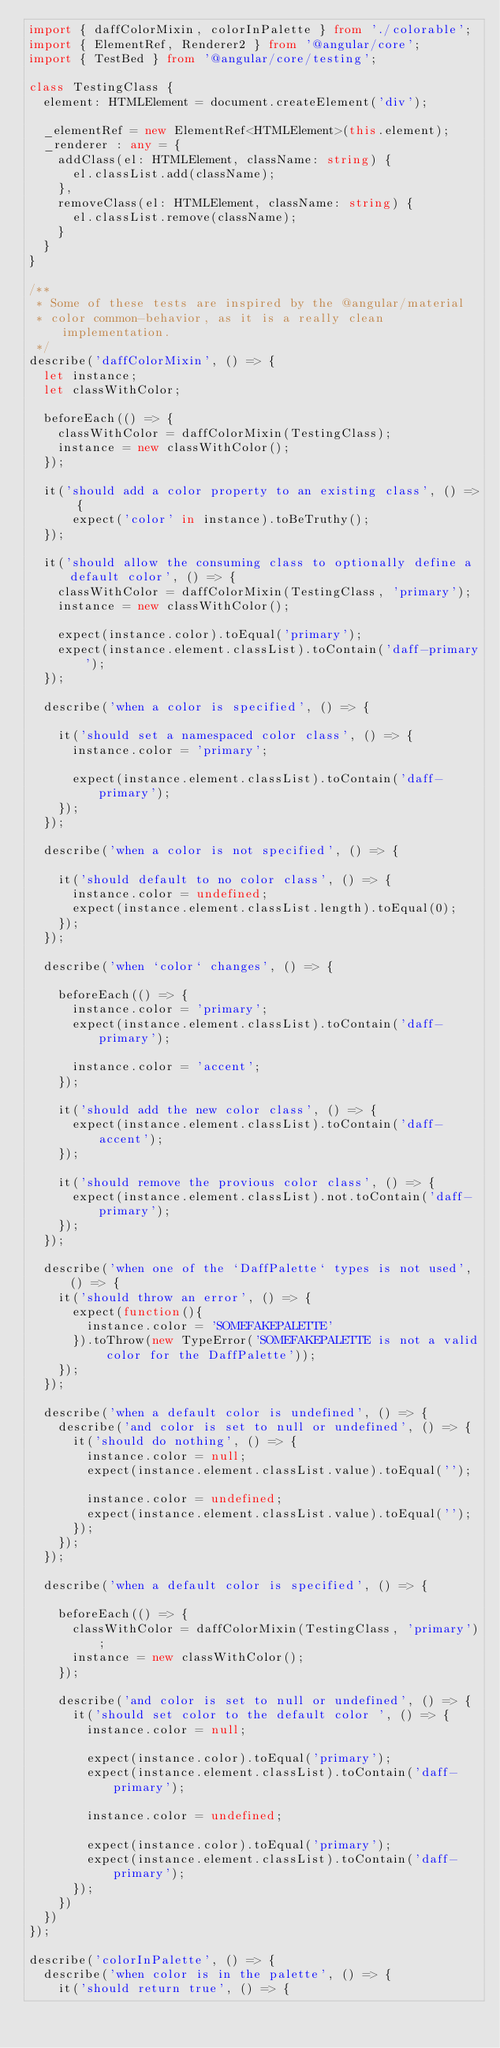Convert code to text. <code><loc_0><loc_0><loc_500><loc_500><_TypeScript_>import { daffColorMixin, colorInPalette } from './colorable';
import { ElementRef, Renderer2 } from '@angular/core';
import { TestBed } from '@angular/core/testing';

class TestingClass {
  element: HTMLElement = document.createElement('div');

  _elementRef = new ElementRef<HTMLElement>(this.element);
  _renderer : any = { 
    addClass(el: HTMLElement, className: string) {
      el.classList.add(className);
    },
    removeClass(el: HTMLElement, className: string) {
      el.classList.remove(className);
    }
  } 
}

/**
 * Some of these tests are inspired by the @angular/material
 * color common-behavior, as it is a really clean implementation.
 */
describe('daffColorMixin', () => {
  let instance;
  let classWithColor;

  beforeEach(() => {
    classWithColor = daffColorMixin(TestingClass);
    instance = new classWithColor();
  });

  it('should add a color property to an existing class', () => {
      expect('color' in instance).toBeTruthy();
  });

  it('should allow the consuming class to optionally define a default color', () => {
    classWithColor = daffColorMixin(TestingClass, 'primary');
    instance = new classWithColor();

    expect(instance.color).toEqual('primary');
    expect(instance.element.classList).toContain('daff-primary');
  });

  describe('when a color is specified', () => {
    
    it('should set a namespaced color class', () => {
      instance.color = 'primary';

      expect(instance.element.classList).toContain('daff-primary');
    });
  });

  describe('when a color is not specified', () => {
    
    it('should default to no color class', () => {
      instance.color = undefined;
      expect(instance.element.classList.length).toEqual(0);
    });
  });

  describe('when `color` changes', () => {

    beforeEach(() => {
      instance.color = 'primary';
      expect(instance.element.classList).toContain('daff-primary');

      instance.color = 'accent';
    });
    
    it('should add the new color class', () => {
      expect(instance.element.classList).toContain('daff-accent');
    });

    it('should remove the provious color class', () => {
      expect(instance.element.classList).not.toContain('daff-primary');
    });
  });

  describe('when one of the `DaffPalette` types is not used', () => {
    it('should throw an error', () => {
      expect(function(){
        instance.color = 'SOMEFAKEPALETTE'
      }).toThrow(new TypeError('SOMEFAKEPALETTE is not a valid color for the DaffPalette'));
    });
  });

  describe('when a default color is undefined', () => {
    describe('and color is set to null or undefined', () => {
      it('should do nothing', () => {
        instance.color = null;
        expect(instance.element.classList.value).toEqual('');

        instance.color = undefined;
        expect(instance.element.classList.value).toEqual('');
      });
    });
  });

  describe('when a default color is specified', () => {

    beforeEach(() => {
      classWithColor = daffColorMixin(TestingClass, 'primary');
      instance = new classWithColor();
    });

    describe('and color is set to null or undefined', () => {
      it('should set color to the default color ', () => {
        instance.color = null;

        expect(instance.color).toEqual('primary');
        expect(instance.element.classList).toContain('daff-primary');

        instance.color = undefined;

        expect(instance.color).toEqual('primary');
        expect(instance.element.classList).toContain('daff-primary');
      });
    })
  })
});

describe('colorInPalette', () => {
  describe('when color is in the palette', () => {
    it('should return true', () => {</code> 